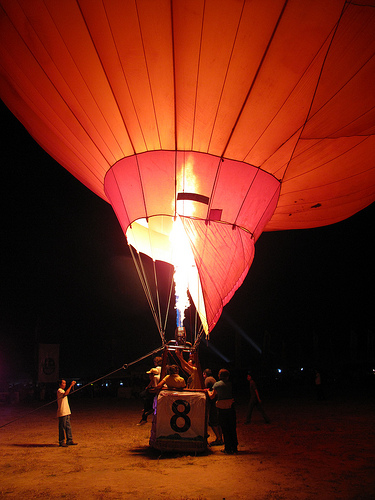<image>
Can you confirm if the fire is in the balloon? Yes. The fire is contained within or inside the balloon, showing a containment relationship. 